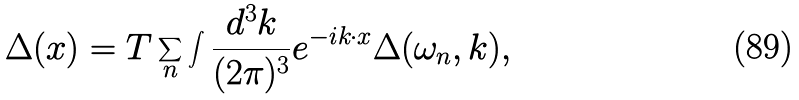Convert formula to latex. <formula><loc_0><loc_0><loc_500><loc_500>\Delta ( x ) = T \sum _ { n } \int \frac { d ^ { 3 } { k } } { ( 2 \pi ) ^ { 3 } } e ^ { - i k \cdot x } \Delta ( \omega _ { n } , { k } ) ,</formula> 